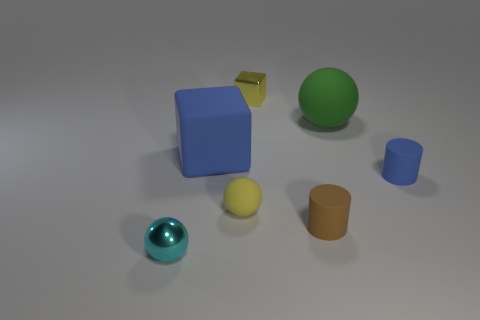Add 3 small blue cylinders. How many objects exist? 10 Subtract all balls. How many objects are left? 4 Add 2 metallic objects. How many metallic objects are left? 4 Add 3 yellow cubes. How many yellow cubes exist? 4 Subtract 0 cyan blocks. How many objects are left? 7 Subtract all large brown shiny things. Subtract all large green spheres. How many objects are left? 6 